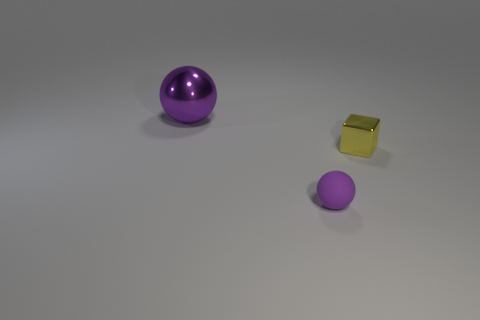Is there anything else that is the same size as the purple metal sphere?
Keep it short and to the point. No. Are there any other things that have the same shape as the small yellow object?
Give a very brief answer. No. There is a yellow shiny block; how many yellow objects are to the right of it?
Keep it short and to the point. 0. There is a object that is the same color as the big metallic ball; what is it made of?
Offer a terse response. Rubber. Are there any small purple rubber objects that have the same shape as the big metal thing?
Keep it short and to the point. Yes. Is the material of the sphere that is behind the small metallic block the same as the block in front of the big metal ball?
Offer a very short reply. Yes. There is a metal object to the left of the shiny object that is in front of the thing left of the purple matte object; what size is it?
Make the answer very short. Large. What material is the object that is the same size as the yellow block?
Your answer should be compact. Rubber. Are there any metallic cubes that have the same size as the purple rubber ball?
Your answer should be very brief. Yes. Is the shape of the large purple object the same as the tiny rubber thing?
Offer a very short reply. Yes. 